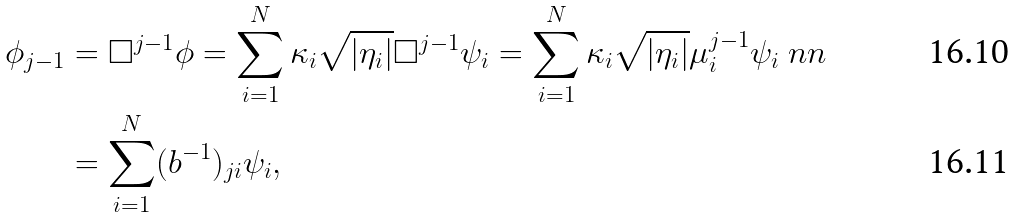<formula> <loc_0><loc_0><loc_500><loc_500>\phi _ { j - 1 } & = \Box ^ { j - 1 } \phi = \sum _ { i = 1 } ^ { N } \kappa _ { i } \sqrt { | \eta _ { i } | } \Box ^ { j - 1 } \psi _ { i } = \sum _ { i = 1 } ^ { N } \kappa _ { i } \sqrt { | \eta _ { i } | } \mu _ { i } ^ { j - 1 } \psi _ { i } \ n n \\ & = \sum _ { i = 1 } ^ { N } ( b ^ { - 1 } ) _ { j i } \psi _ { i } ,</formula> 